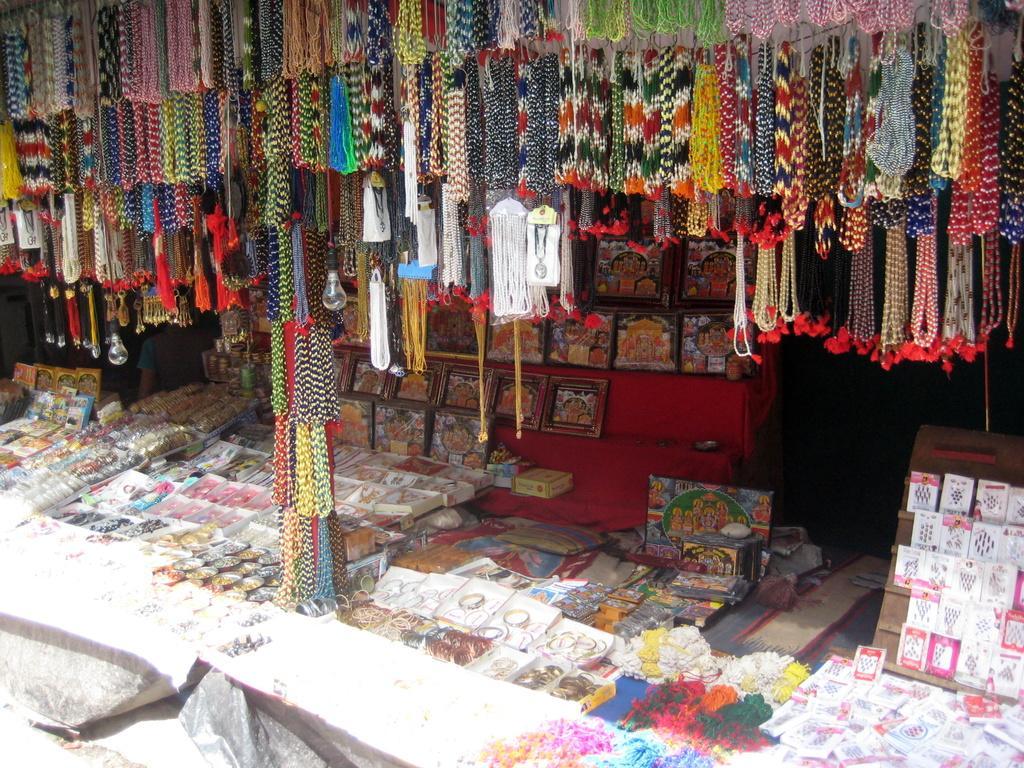Please provide a concise description of this image. In the foreground of this picture we can see the tables on the top of which bangles, picture frames and many other items are placed and we can see the lights and the jewelry hanging. In the background we can see many other objects. 